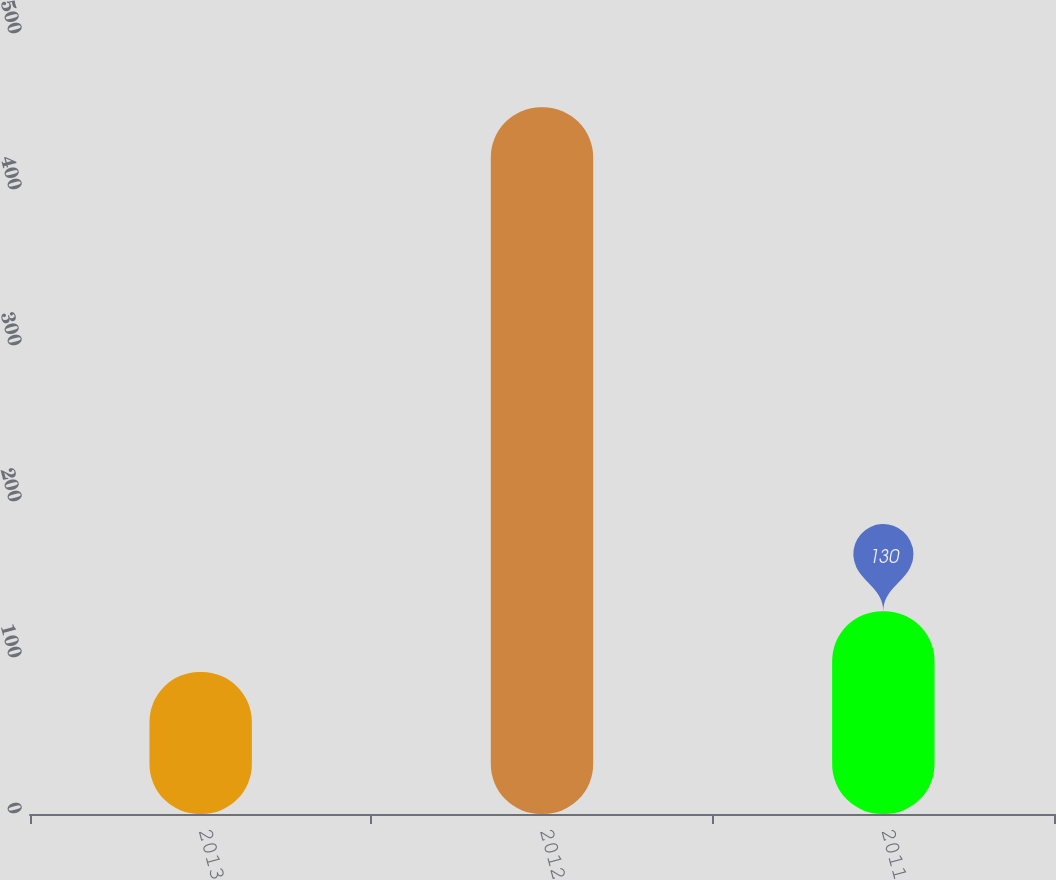<chart> <loc_0><loc_0><loc_500><loc_500><bar_chart><fcel>2013<fcel>2012<fcel>2011<nl><fcel>91<fcel>453<fcel>130<nl></chart> 